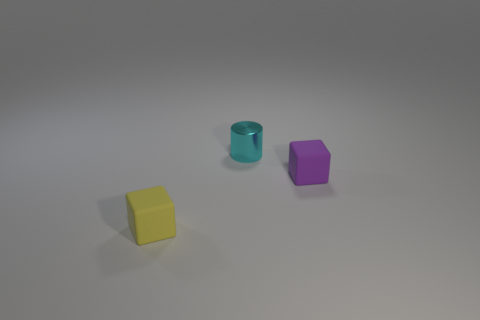The object that is both behind the yellow cube and in front of the small cyan metal cylinder has what shape?
Provide a short and direct response. Cube. Is there a cylinder of the same size as the yellow rubber cube?
Your answer should be very brief. Yes. There is a object that is in front of the purple matte object; is its shape the same as the cyan thing?
Make the answer very short. No. Is the small cyan shiny object the same shape as the purple matte object?
Your answer should be very brief. No. Is there a red thing of the same shape as the small purple matte thing?
Your answer should be compact. No. What is the shape of the cyan shiny object behind the object in front of the tiny purple cube?
Your response must be concise. Cylinder. There is a cube left of the purple rubber block; what is its color?
Your answer should be very brief. Yellow. There is a purple cube that is the same material as the tiny yellow object; what size is it?
Make the answer very short. Small. There is another rubber thing that is the same shape as the tiny purple rubber object; what size is it?
Provide a short and direct response. Small. Are there any tiny cyan cylinders?
Your answer should be compact. Yes. 